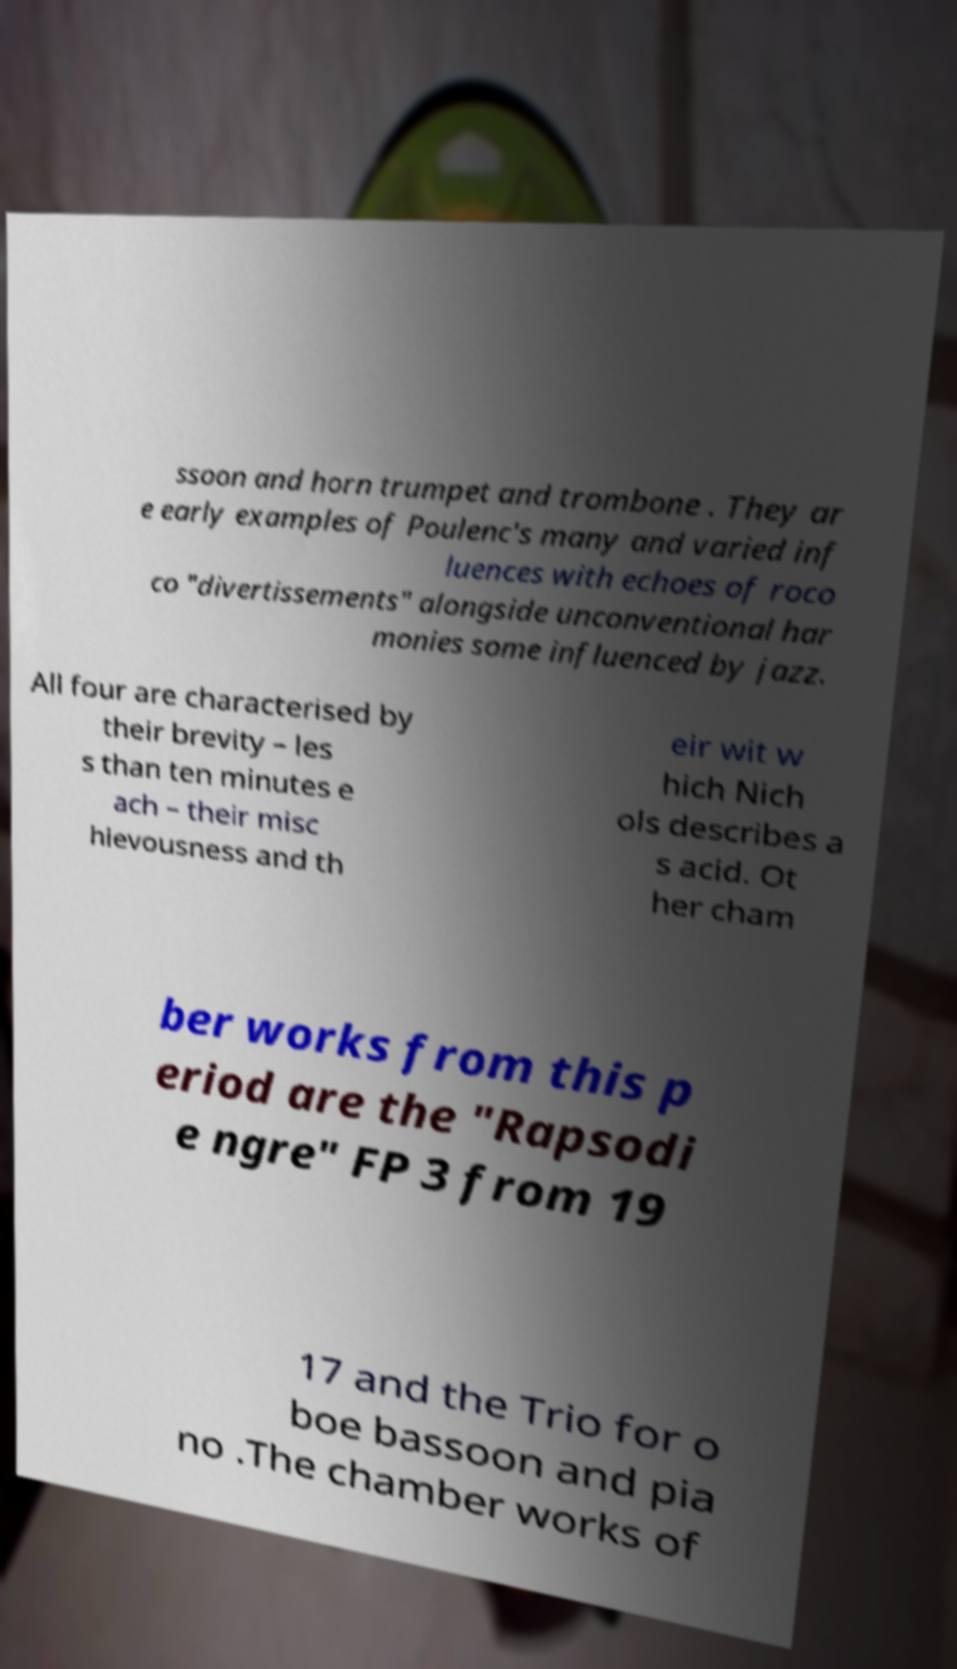Could you extract and type out the text from this image? ssoon and horn trumpet and trombone . They ar e early examples of Poulenc's many and varied inf luences with echoes of roco co "divertissements" alongside unconventional har monies some influenced by jazz. All four are characterised by their brevity – les s than ten minutes e ach – their misc hievousness and th eir wit w hich Nich ols describes a s acid. Ot her cham ber works from this p eriod are the "Rapsodi e ngre" FP 3 from 19 17 and the Trio for o boe bassoon and pia no .The chamber works of 